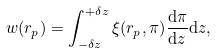Convert formula to latex. <formula><loc_0><loc_0><loc_500><loc_500>w ( r _ { p } ) = \int _ { - \delta z } ^ { + \delta z } { \xi ( r _ { p } , \pi ) \frac { { \mathrm d } \pi } { { \mathrm d } z } { \mathrm d } z } ,</formula> 